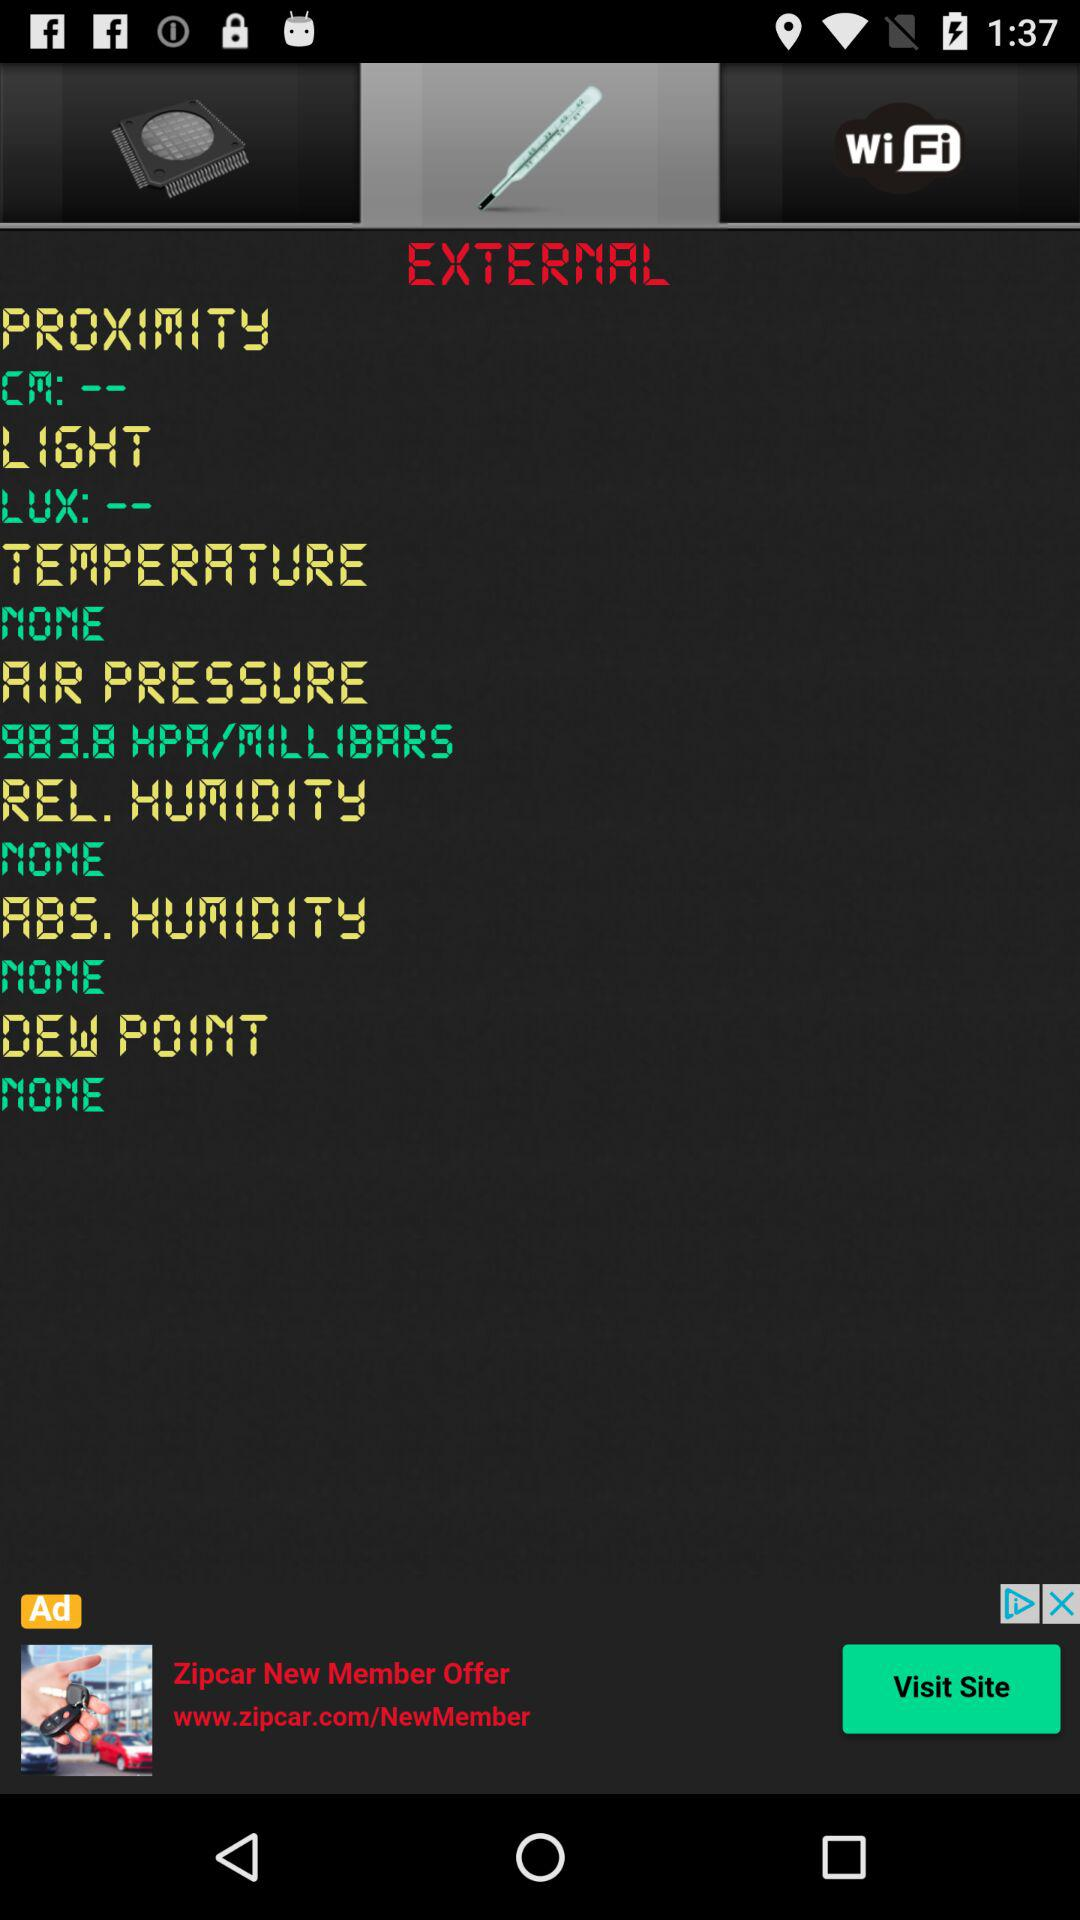What is the unit of light? The unit of light is "LUX". 